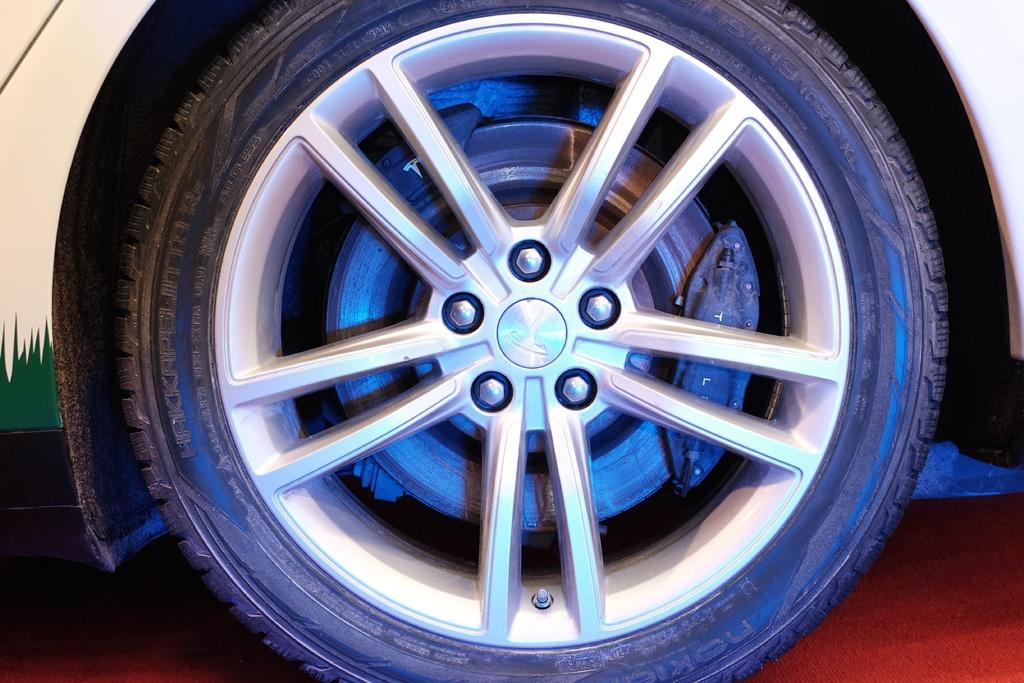What is the main object in the image? There is a wheel in the image. What else is present in the image related to the wheel? There is a tyre in the image. What is the purpose of the wheel and tyre in the image? The wheel and tyre belong to a vehicle. What type of land can be seen in the image? There is no land visible in the image; it only features a wheel and a tyre. How does the pump function in the image? There is no pump present in the image. 